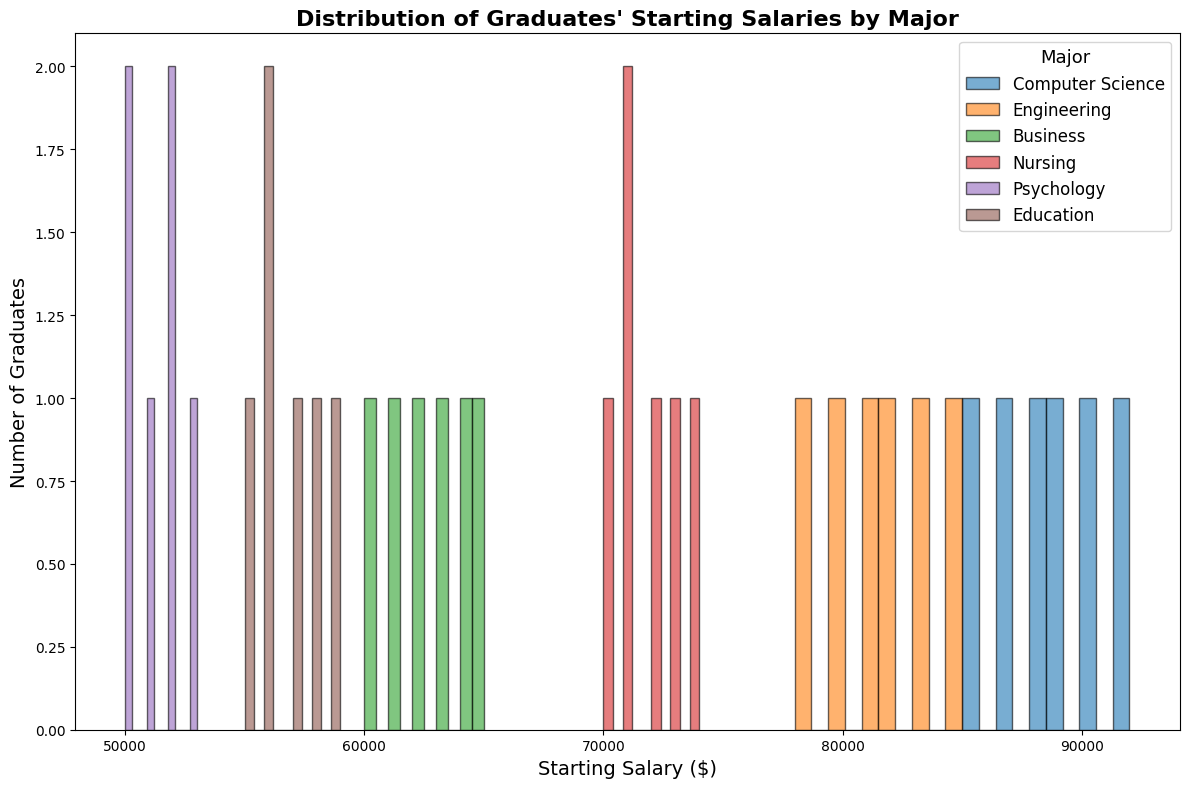What major has the highest starting salary on average? First, you identify the majors in the figure. Then, visually estimate the average starting salary for each major by looking at the center of the distribution of the bars. The highest center will correspond to the major with the highest average starting salary.
Answer: Computer Science Which major has the widest range of starting salaries? Observe the spread of the bars for each major. The major with the most extended range of bars from highest to lowest salary indicates the widest range.
Answer: Computer Science How many graduates in Computer Science have starting salaries above $85,000? Locate the bars corresponding to Computer Science, find the bars that are above the $85,000 mark, and count the number of bars.
Answer: 4 What is the most common starting salary range for Nursing graduates? Observe the histogram bars for Nursing and identify the salary range where the bars are the highest, indicating the most common range.
Answer: $70,000 - $74,000 Compare the starting salaries of Engineering and Business graduates. Which group has higher starting salaries overall? Look at the histograms for Engineering and Business. Notice the peak and spread of the bars to determine which group has generally higher starting salaries. The bars for Engineering are higher and spread in a higher salary range compared to Business.
Answer: Engineering What starting salary range do the majority of Education graduates fall into? Observe the bars for Education and identify the range where most of the bars are concentrated.
Answer: $55,000 - $59,000 Estimate the average starting salary for Psychology graduates based on the histogram. Locate the histogram for Psychology and visually determine the central point of the distribution, which provides an estimate for the average starting salary.
Answer: Approximately $51,000 Which major has more graduates with starting salaries below $60,000? Compare the number of bars below the $60,000 mark for each major. Psychology and Business have bars below $60,000, with Psychology having more graduates in this range.
Answer: Psychology 